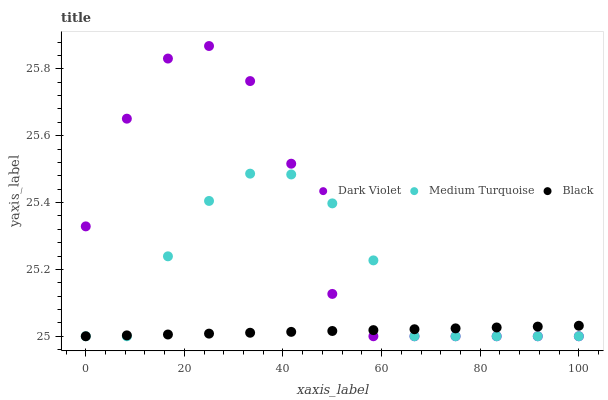Does Black have the minimum area under the curve?
Answer yes or no. Yes. Does Dark Violet have the maximum area under the curve?
Answer yes or no. Yes. Does Medium Turquoise have the minimum area under the curve?
Answer yes or no. No. Does Medium Turquoise have the maximum area under the curve?
Answer yes or no. No. Is Black the smoothest?
Answer yes or no. Yes. Is Dark Violet the roughest?
Answer yes or no. Yes. Is Medium Turquoise the smoothest?
Answer yes or no. No. Is Medium Turquoise the roughest?
Answer yes or no. No. Does Black have the lowest value?
Answer yes or no. Yes. Does Dark Violet have the highest value?
Answer yes or no. Yes. Does Medium Turquoise have the highest value?
Answer yes or no. No. Does Black intersect Dark Violet?
Answer yes or no. Yes. Is Black less than Dark Violet?
Answer yes or no. No. Is Black greater than Dark Violet?
Answer yes or no. No. 